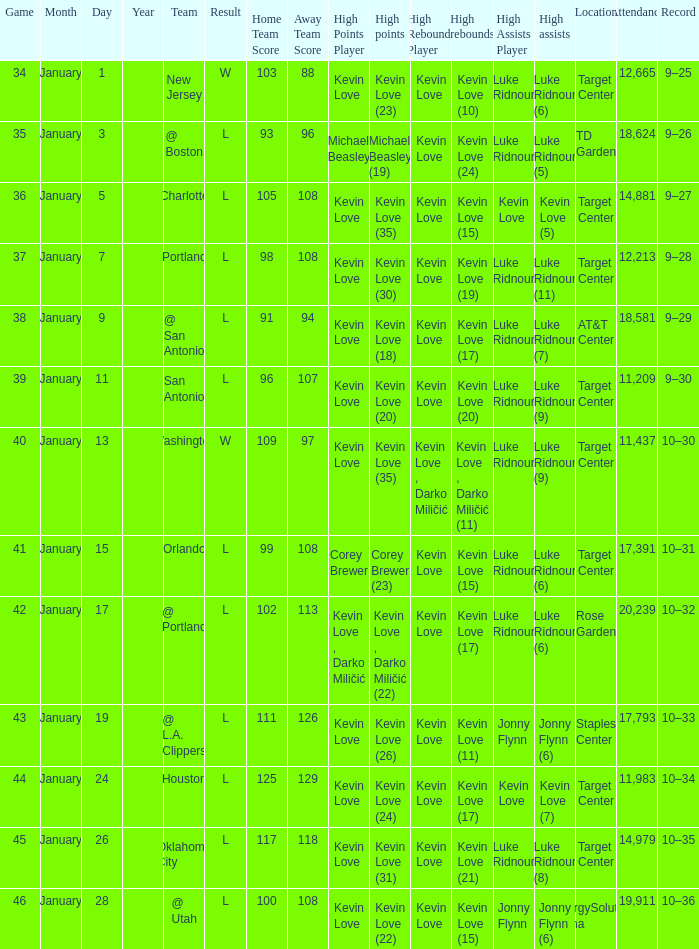What is the date for the game with team orlando? January 15. 